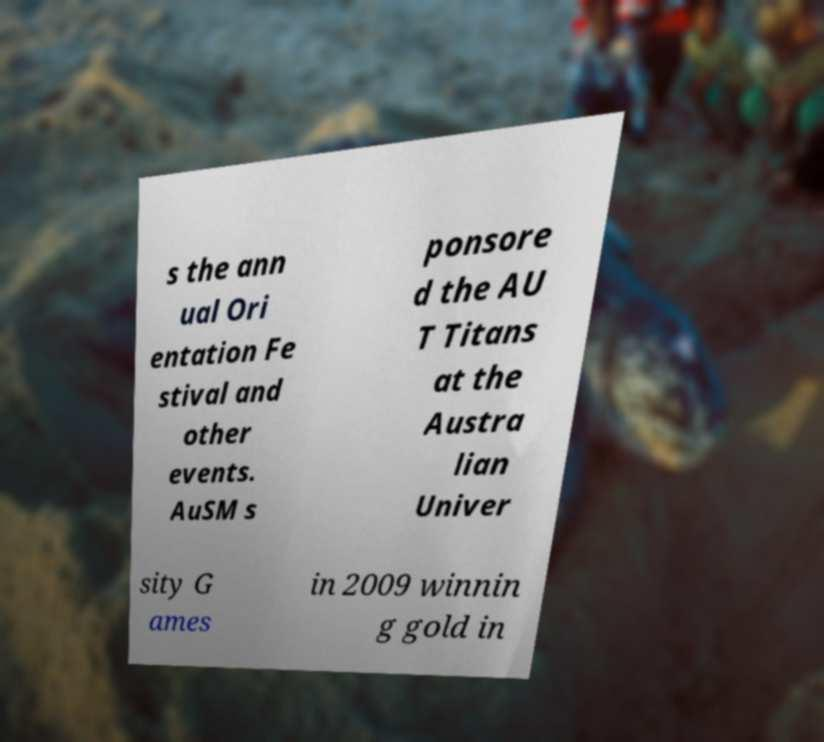For documentation purposes, I need the text within this image transcribed. Could you provide that? s the ann ual Ori entation Fe stival and other events. AuSM s ponsore d the AU T Titans at the Austra lian Univer sity G ames in 2009 winnin g gold in 